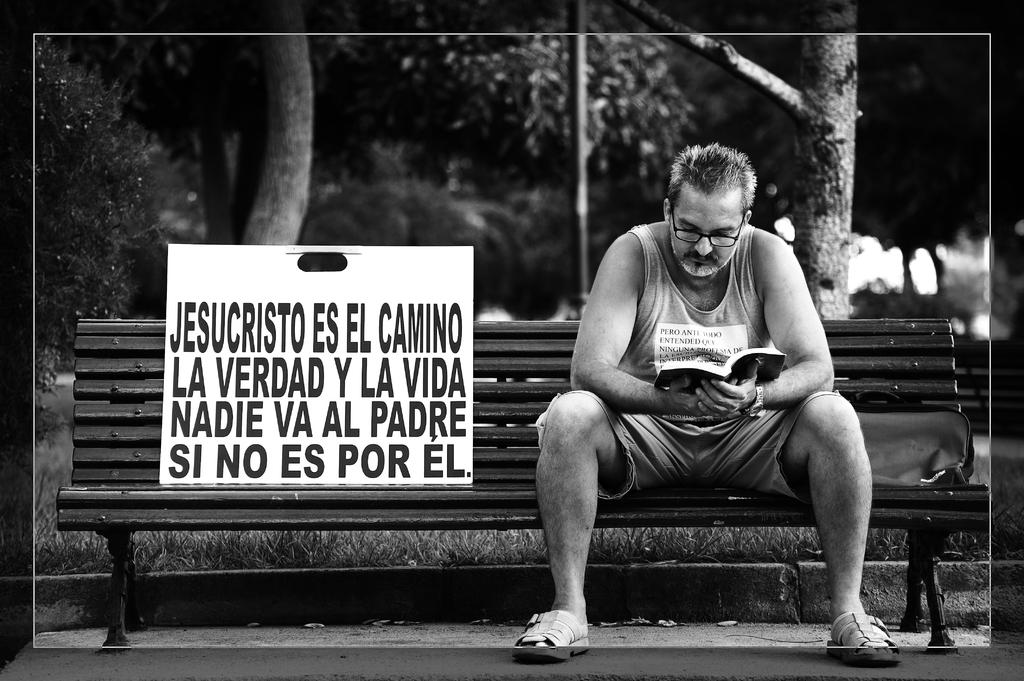Who is present in the image? There is a man in the image. What is the man doing in the image? The man is sitting on a chair and reading a book. What can be seen in the background of the image? There are trees in the background of the image. What type of soup is the man eating in the image? There is no soup present in the image; the man is reading a book. Is the man a spy in the image? There is no information in the image to suggest that the man is a spy. 